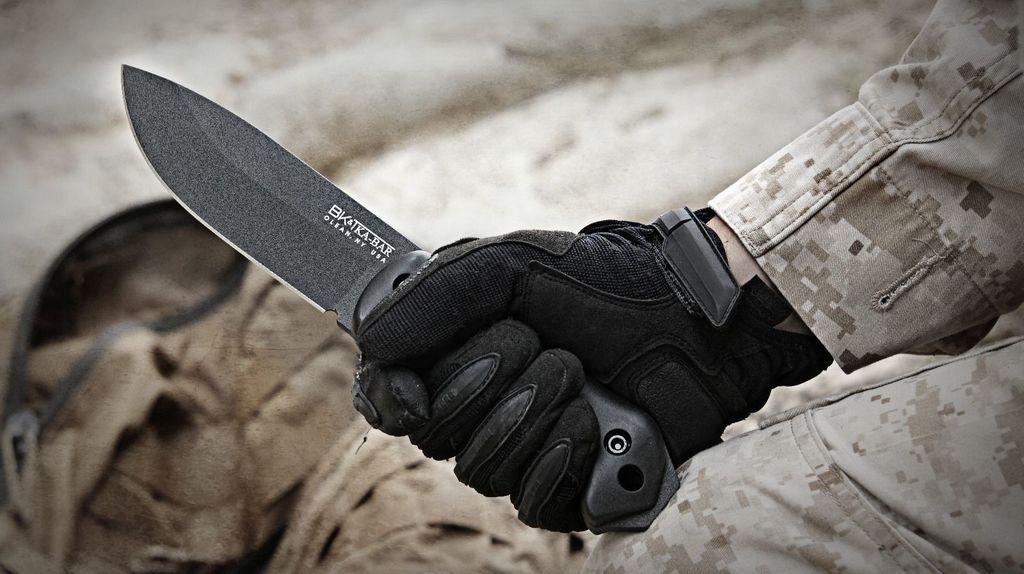Could you give a brief overview of what you see in this image? In this picture we can observe a knife which is in black color. There is a human hand holding a knife wearing a black color glove. In the background it is completely blur. 